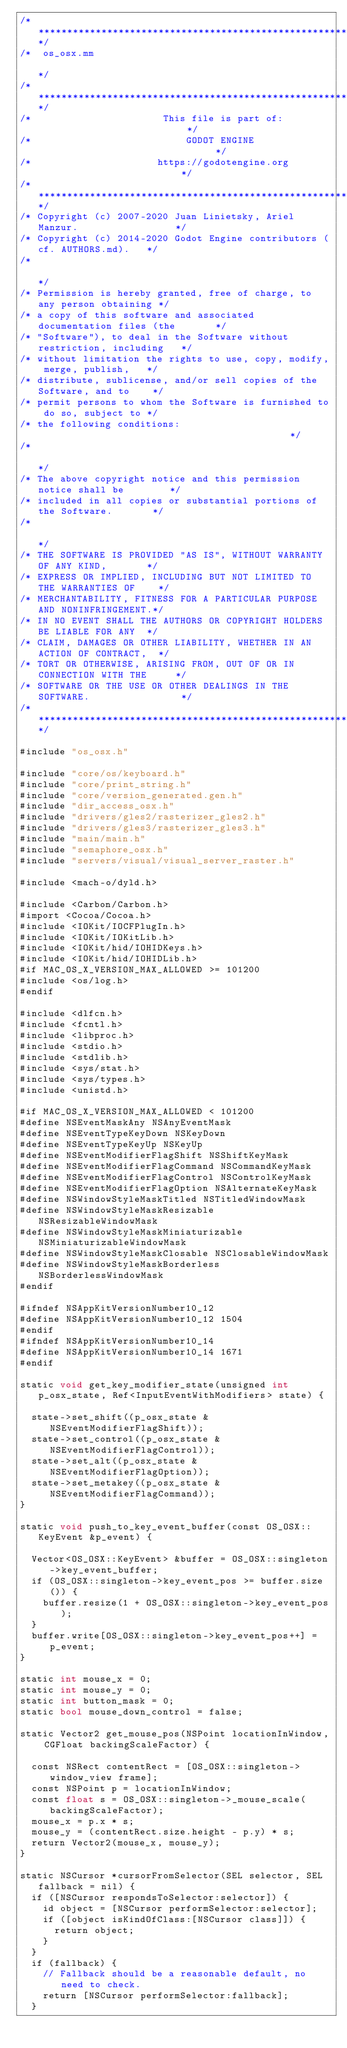<code> <loc_0><loc_0><loc_500><loc_500><_ObjectiveC_>/*************************************************************************/
/*  os_osx.mm                                                            */
/*************************************************************************/
/*                       This file is part of:                           */
/*                           GODOT ENGINE                                */
/*                      https://godotengine.org                          */
/*************************************************************************/
/* Copyright (c) 2007-2020 Juan Linietsky, Ariel Manzur.                 */
/* Copyright (c) 2014-2020 Godot Engine contributors (cf. AUTHORS.md).   */
/*                                                                       */
/* Permission is hereby granted, free of charge, to any person obtaining */
/* a copy of this software and associated documentation files (the       */
/* "Software"), to deal in the Software without restriction, including   */
/* without limitation the rights to use, copy, modify, merge, publish,   */
/* distribute, sublicense, and/or sell copies of the Software, and to    */
/* permit persons to whom the Software is furnished to do so, subject to */
/* the following conditions:                                             */
/*                                                                       */
/* The above copyright notice and this permission notice shall be        */
/* included in all copies or substantial portions of the Software.       */
/*                                                                       */
/* THE SOFTWARE IS PROVIDED "AS IS", WITHOUT WARRANTY OF ANY KIND,       */
/* EXPRESS OR IMPLIED, INCLUDING BUT NOT LIMITED TO THE WARRANTIES OF    */
/* MERCHANTABILITY, FITNESS FOR A PARTICULAR PURPOSE AND NONINFRINGEMENT.*/
/* IN NO EVENT SHALL THE AUTHORS OR COPYRIGHT HOLDERS BE LIABLE FOR ANY  */
/* CLAIM, DAMAGES OR OTHER LIABILITY, WHETHER IN AN ACTION OF CONTRACT,  */
/* TORT OR OTHERWISE, ARISING FROM, OUT OF OR IN CONNECTION WITH THE     */
/* SOFTWARE OR THE USE OR OTHER DEALINGS IN THE SOFTWARE.                */
/*************************************************************************/

#include "os_osx.h"

#include "core/os/keyboard.h"
#include "core/print_string.h"
#include "core/version_generated.gen.h"
#include "dir_access_osx.h"
#include "drivers/gles2/rasterizer_gles2.h"
#include "drivers/gles3/rasterizer_gles3.h"
#include "main/main.h"
#include "semaphore_osx.h"
#include "servers/visual/visual_server_raster.h"

#include <mach-o/dyld.h>

#include <Carbon/Carbon.h>
#import <Cocoa/Cocoa.h>
#include <IOKit/IOCFPlugIn.h>
#include <IOKit/IOKitLib.h>
#include <IOKit/hid/IOHIDKeys.h>
#include <IOKit/hid/IOHIDLib.h>
#if MAC_OS_X_VERSION_MAX_ALLOWED >= 101200
#include <os/log.h>
#endif

#include <dlfcn.h>
#include <fcntl.h>
#include <libproc.h>
#include <stdio.h>
#include <stdlib.h>
#include <sys/stat.h>
#include <sys/types.h>
#include <unistd.h>

#if MAC_OS_X_VERSION_MAX_ALLOWED < 101200
#define NSEventMaskAny NSAnyEventMask
#define NSEventTypeKeyDown NSKeyDown
#define NSEventTypeKeyUp NSKeyUp
#define NSEventModifierFlagShift NSShiftKeyMask
#define NSEventModifierFlagCommand NSCommandKeyMask
#define NSEventModifierFlagControl NSControlKeyMask
#define NSEventModifierFlagOption NSAlternateKeyMask
#define NSWindowStyleMaskTitled NSTitledWindowMask
#define NSWindowStyleMaskResizable NSResizableWindowMask
#define NSWindowStyleMaskMiniaturizable NSMiniaturizableWindowMask
#define NSWindowStyleMaskClosable NSClosableWindowMask
#define NSWindowStyleMaskBorderless NSBorderlessWindowMask
#endif

#ifndef NSAppKitVersionNumber10_12
#define NSAppKitVersionNumber10_12 1504
#endif
#ifndef NSAppKitVersionNumber10_14
#define NSAppKitVersionNumber10_14 1671
#endif

static void get_key_modifier_state(unsigned int p_osx_state, Ref<InputEventWithModifiers> state) {

	state->set_shift((p_osx_state & NSEventModifierFlagShift));
	state->set_control((p_osx_state & NSEventModifierFlagControl));
	state->set_alt((p_osx_state & NSEventModifierFlagOption));
	state->set_metakey((p_osx_state & NSEventModifierFlagCommand));
}

static void push_to_key_event_buffer(const OS_OSX::KeyEvent &p_event) {

	Vector<OS_OSX::KeyEvent> &buffer = OS_OSX::singleton->key_event_buffer;
	if (OS_OSX::singleton->key_event_pos >= buffer.size()) {
		buffer.resize(1 + OS_OSX::singleton->key_event_pos);
	}
	buffer.write[OS_OSX::singleton->key_event_pos++] = p_event;
}

static int mouse_x = 0;
static int mouse_y = 0;
static int button_mask = 0;
static bool mouse_down_control = false;

static Vector2 get_mouse_pos(NSPoint locationInWindow, CGFloat backingScaleFactor) {

	const NSRect contentRect = [OS_OSX::singleton->window_view frame];
	const NSPoint p = locationInWindow;
	const float s = OS_OSX::singleton->_mouse_scale(backingScaleFactor);
	mouse_x = p.x * s;
	mouse_y = (contentRect.size.height - p.y) * s;
	return Vector2(mouse_x, mouse_y);
}

static NSCursor *cursorFromSelector(SEL selector, SEL fallback = nil) {
	if ([NSCursor respondsToSelector:selector]) {
		id object = [NSCursor performSelector:selector];
		if ([object isKindOfClass:[NSCursor class]]) {
			return object;
		}
	}
	if (fallback) {
		// Fallback should be a reasonable default, no need to check.
		return [NSCursor performSelector:fallback];
	}</code> 